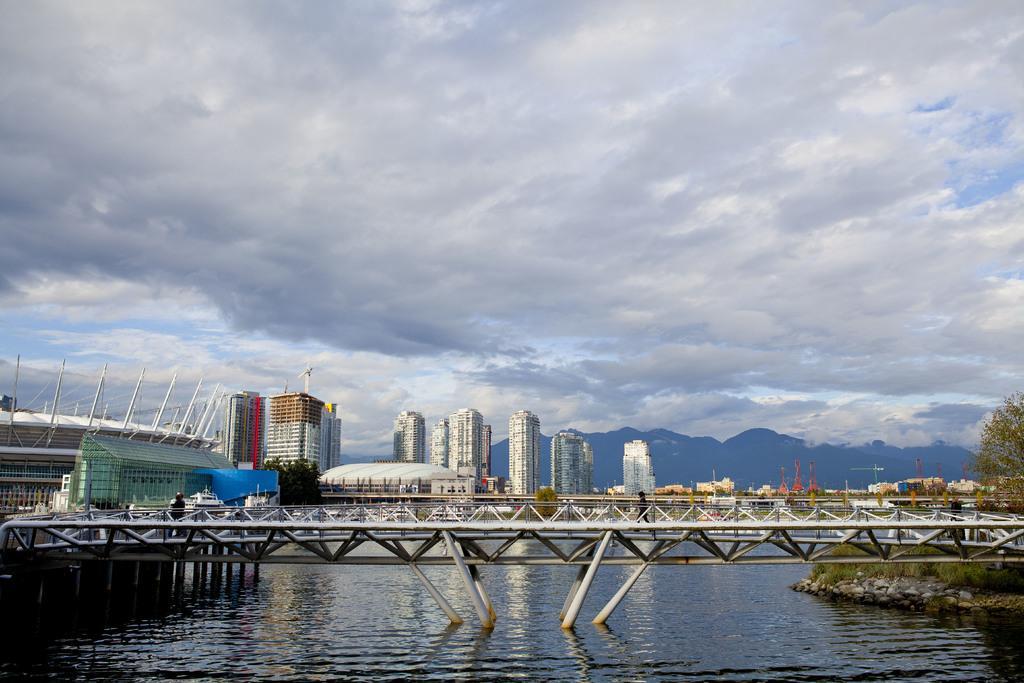Could you give a brief overview of what you see in this image? In this image we can see a bridge in the water and there are few people on the bridge. Behind the bridge we can see a group of buildings and mountains. At the top we can see the sky. On the right side, we can see few plants and a tree. At the bottom we can see the water. 